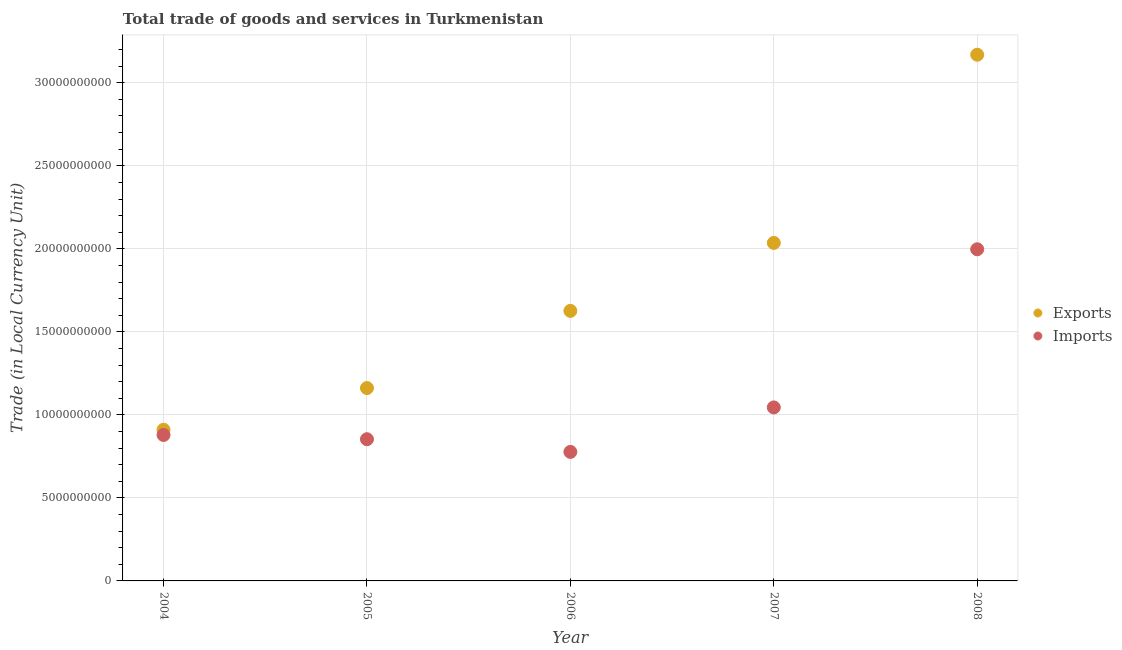Is the number of dotlines equal to the number of legend labels?
Your answer should be very brief. Yes. What is the export of goods and services in 2004?
Your response must be concise. 9.10e+09. Across all years, what is the maximum export of goods and services?
Make the answer very short. 3.17e+1. Across all years, what is the minimum imports of goods and services?
Keep it short and to the point. 7.77e+09. In which year was the imports of goods and services maximum?
Your answer should be very brief. 2008. What is the total imports of goods and services in the graph?
Provide a succinct answer. 5.55e+1. What is the difference between the imports of goods and services in 2006 and that in 2007?
Keep it short and to the point. -2.68e+09. What is the difference between the export of goods and services in 2006 and the imports of goods and services in 2004?
Your response must be concise. 7.47e+09. What is the average export of goods and services per year?
Offer a terse response. 1.78e+1. In the year 2006, what is the difference between the imports of goods and services and export of goods and services?
Provide a short and direct response. -8.49e+09. What is the ratio of the export of goods and services in 2005 to that in 2007?
Offer a terse response. 0.57. Is the imports of goods and services in 2006 less than that in 2007?
Your answer should be compact. Yes. Is the difference between the export of goods and services in 2006 and 2008 greater than the difference between the imports of goods and services in 2006 and 2008?
Your answer should be very brief. No. What is the difference between the highest and the second highest export of goods and services?
Ensure brevity in your answer.  1.13e+1. What is the difference between the highest and the lowest imports of goods and services?
Your answer should be very brief. 1.22e+1. Is the sum of the imports of goods and services in 2006 and 2008 greater than the maximum export of goods and services across all years?
Provide a short and direct response. No. How many dotlines are there?
Your answer should be very brief. 2. Does the graph contain any zero values?
Your answer should be very brief. No. Where does the legend appear in the graph?
Provide a short and direct response. Center right. How many legend labels are there?
Keep it short and to the point. 2. What is the title of the graph?
Give a very brief answer. Total trade of goods and services in Turkmenistan. What is the label or title of the X-axis?
Offer a terse response. Year. What is the label or title of the Y-axis?
Give a very brief answer. Trade (in Local Currency Unit). What is the Trade (in Local Currency Unit) of Exports in 2004?
Give a very brief answer. 9.10e+09. What is the Trade (in Local Currency Unit) in Imports in 2004?
Ensure brevity in your answer.  8.79e+09. What is the Trade (in Local Currency Unit) in Exports in 2005?
Your response must be concise. 1.16e+1. What is the Trade (in Local Currency Unit) of Imports in 2005?
Your answer should be very brief. 8.53e+09. What is the Trade (in Local Currency Unit) of Exports in 2006?
Your answer should be very brief. 1.63e+1. What is the Trade (in Local Currency Unit) in Imports in 2006?
Offer a very short reply. 7.77e+09. What is the Trade (in Local Currency Unit) of Exports in 2007?
Your answer should be compact. 2.04e+1. What is the Trade (in Local Currency Unit) of Imports in 2007?
Keep it short and to the point. 1.04e+1. What is the Trade (in Local Currency Unit) of Exports in 2008?
Offer a very short reply. 3.17e+1. What is the Trade (in Local Currency Unit) in Imports in 2008?
Make the answer very short. 2.00e+1. Across all years, what is the maximum Trade (in Local Currency Unit) of Exports?
Give a very brief answer. 3.17e+1. Across all years, what is the maximum Trade (in Local Currency Unit) of Imports?
Your answer should be very brief. 2.00e+1. Across all years, what is the minimum Trade (in Local Currency Unit) in Exports?
Your answer should be very brief. 9.10e+09. Across all years, what is the minimum Trade (in Local Currency Unit) in Imports?
Provide a short and direct response. 7.77e+09. What is the total Trade (in Local Currency Unit) of Exports in the graph?
Offer a terse response. 8.90e+1. What is the total Trade (in Local Currency Unit) in Imports in the graph?
Provide a short and direct response. 5.55e+1. What is the difference between the Trade (in Local Currency Unit) in Exports in 2004 and that in 2005?
Offer a very short reply. -2.51e+09. What is the difference between the Trade (in Local Currency Unit) in Imports in 2004 and that in 2005?
Provide a succinct answer. 2.55e+08. What is the difference between the Trade (in Local Currency Unit) in Exports in 2004 and that in 2006?
Make the answer very short. -7.16e+09. What is the difference between the Trade (in Local Currency Unit) in Imports in 2004 and that in 2006?
Give a very brief answer. 1.02e+09. What is the difference between the Trade (in Local Currency Unit) of Exports in 2004 and that in 2007?
Offer a terse response. -1.13e+1. What is the difference between the Trade (in Local Currency Unit) of Imports in 2004 and that in 2007?
Offer a terse response. -1.66e+09. What is the difference between the Trade (in Local Currency Unit) in Exports in 2004 and that in 2008?
Provide a succinct answer. -2.26e+1. What is the difference between the Trade (in Local Currency Unit) of Imports in 2004 and that in 2008?
Provide a short and direct response. -1.12e+1. What is the difference between the Trade (in Local Currency Unit) in Exports in 2005 and that in 2006?
Provide a succinct answer. -4.65e+09. What is the difference between the Trade (in Local Currency Unit) of Imports in 2005 and that in 2006?
Give a very brief answer. 7.64e+08. What is the difference between the Trade (in Local Currency Unit) in Exports in 2005 and that in 2007?
Give a very brief answer. -8.74e+09. What is the difference between the Trade (in Local Currency Unit) of Imports in 2005 and that in 2007?
Your response must be concise. -1.92e+09. What is the difference between the Trade (in Local Currency Unit) in Exports in 2005 and that in 2008?
Offer a terse response. -2.01e+1. What is the difference between the Trade (in Local Currency Unit) of Imports in 2005 and that in 2008?
Provide a succinct answer. -1.14e+1. What is the difference between the Trade (in Local Currency Unit) of Exports in 2006 and that in 2007?
Your answer should be very brief. -4.09e+09. What is the difference between the Trade (in Local Currency Unit) of Imports in 2006 and that in 2007?
Ensure brevity in your answer.  -2.68e+09. What is the difference between the Trade (in Local Currency Unit) in Exports in 2006 and that in 2008?
Your response must be concise. -1.54e+1. What is the difference between the Trade (in Local Currency Unit) in Imports in 2006 and that in 2008?
Offer a very short reply. -1.22e+1. What is the difference between the Trade (in Local Currency Unit) of Exports in 2007 and that in 2008?
Offer a very short reply. -1.13e+1. What is the difference between the Trade (in Local Currency Unit) in Imports in 2007 and that in 2008?
Your answer should be compact. -9.52e+09. What is the difference between the Trade (in Local Currency Unit) in Exports in 2004 and the Trade (in Local Currency Unit) in Imports in 2005?
Make the answer very short. 5.68e+08. What is the difference between the Trade (in Local Currency Unit) of Exports in 2004 and the Trade (in Local Currency Unit) of Imports in 2006?
Your answer should be very brief. 1.33e+09. What is the difference between the Trade (in Local Currency Unit) of Exports in 2004 and the Trade (in Local Currency Unit) of Imports in 2007?
Your response must be concise. -1.35e+09. What is the difference between the Trade (in Local Currency Unit) of Exports in 2004 and the Trade (in Local Currency Unit) of Imports in 2008?
Keep it short and to the point. -1.09e+1. What is the difference between the Trade (in Local Currency Unit) in Exports in 2005 and the Trade (in Local Currency Unit) in Imports in 2006?
Give a very brief answer. 3.84e+09. What is the difference between the Trade (in Local Currency Unit) of Exports in 2005 and the Trade (in Local Currency Unit) of Imports in 2007?
Make the answer very short. 1.17e+09. What is the difference between the Trade (in Local Currency Unit) in Exports in 2005 and the Trade (in Local Currency Unit) in Imports in 2008?
Your answer should be compact. -8.36e+09. What is the difference between the Trade (in Local Currency Unit) of Exports in 2006 and the Trade (in Local Currency Unit) of Imports in 2007?
Provide a succinct answer. 5.81e+09. What is the difference between the Trade (in Local Currency Unit) of Exports in 2006 and the Trade (in Local Currency Unit) of Imports in 2008?
Offer a very short reply. -3.71e+09. What is the difference between the Trade (in Local Currency Unit) of Exports in 2007 and the Trade (in Local Currency Unit) of Imports in 2008?
Ensure brevity in your answer.  3.83e+08. What is the average Trade (in Local Currency Unit) of Exports per year?
Provide a succinct answer. 1.78e+1. What is the average Trade (in Local Currency Unit) in Imports per year?
Your answer should be very brief. 1.11e+1. In the year 2004, what is the difference between the Trade (in Local Currency Unit) of Exports and Trade (in Local Currency Unit) of Imports?
Offer a very short reply. 3.13e+08. In the year 2005, what is the difference between the Trade (in Local Currency Unit) in Exports and Trade (in Local Currency Unit) in Imports?
Your answer should be compact. 3.08e+09. In the year 2006, what is the difference between the Trade (in Local Currency Unit) in Exports and Trade (in Local Currency Unit) in Imports?
Keep it short and to the point. 8.49e+09. In the year 2007, what is the difference between the Trade (in Local Currency Unit) of Exports and Trade (in Local Currency Unit) of Imports?
Give a very brief answer. 9.91e+09. In the year 2008, what is the difference between the Trade (in Local Currency Unit) in Exports and Trade (in Local Currency Unit) in Imports?
Provide a succinct answer. 1.17e+1. What is the ratio of the Trade (in Local Currency Unit) of Exports in 2004 to that in 2005?
Ensure brevity in your answer.  0.78. What is the ratio of the Trade (in Local Currency Unit) in Imports in 2004 to that in 2005?
Your answer should be compact. 1.03. What is the ratio of the Trade (in Local Currency Unit) in Exports in 2004 to that in 2006?
Your response must be concise. 0.56. What is the ratio of the Trade (in Local Currency Unit) in Imports in 2004 to that in 2006?
Ensure brevity in your answer.  1.13. What is the ratio of the Trade (in Local Currency Unit) in Exports in 2004 to that in 2007?
Keep it short and to the point. 0.45. What is the ratio of the Trade (in Local Currency Unit) in Imports in 2004 to that in 2007?
Offer a very short reply. 0.84. What is the ratio of the Trade (in Local Currency Unit) in Exports in 2004 to that in 2008?
Make the answer very short. 0.29. What is the ratio of the Trade (in Local Currency Unit) in Imports in 2004 to that in 2008?
Provide a short and direct response. 0.44. What is the ratio of the Trade (in Local Currency Unit) in Exports in 2005 to that in 2006?
Give a very brief answer. 0.71. What is the ratio of the Trade (in Local Currency Unit) of Imports in 2005 to that in 2006?
Your answer should be very brief. 1.1. What is the ratio of the Trade (in Local Currency Unit) in Exports in 2005 to that in 2007?
Your answer should be compact. 0.57. What is the ratio of the Trade (in Local Currency Unit) in Imports in 2005 to that in 2007?
Provide a succinct answer. 0.82. What is the ratio of the Trade (in Local Currency Unit) in Exports in 2005 to that in 2008?
Your answer should be compact. 0.37. What is the ratio of the Trade (in Local Currency Unit) in Imports in 2005 to that in 2008?
Keep it short and to the point. 0.43. What is the ratio of the Trade (in Local Currency Unit) in Exports in 2006 to that in 2007?
Offer a very short reply. 0.8. What is the ratio of the Trade (in Local Currency Unit) in Imports in 2006 to that in 2007?
Provide a succinct answer. 0.74. What is the ratio of the Trade (in Local Currency Unit) in Exports in 2006 to that in 2008?
Keep it short and to the point. 0.51. What is the ratio of the Trade (in Local Currency Unit) in Imports in 2006 to that in 2008?
Your response must be concise. 0.39. What is the ratio of the Trade (in Local Currency Unit) in Exports in 2007 to that in 2008?
Your response must be concise. 0.64. What is the ratio of the Trade (in Local Currency Unit) in Imports in 2007 to that in 2008?
Your answer should be compact. 0.52. What is the difference between the highest and the second highest Trade (in Local Currency Unit) of Exports?
Your response must be concise. 1.13e+1. What is the difference between the highest and the second highest Trade (in Local Currency Unit) of Imports?
Offer a terse response. 9.52e+09. What is the difference between the highest and the lowest Trade (in Local Currency Unit) in Exports?
Provide a succinct answer. 2.26e+1. What is the difference between the highest and the lowest Trade (in Local Currency Unit) of Imports?
Ensure brevity in your answer.  1.22e+1. 